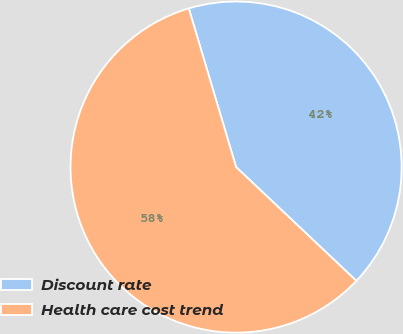Convert chart. <chart><loc_0><loc_0><loc_500><loc_500><pie_chart><fcel>Discount rate<fcel>Health care cost trend<nl><fcel>41.67%<fcel>58.33%<nl></chart> 